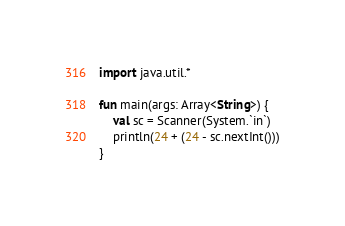<code> <loc_0><loc_0><loc_500><loc_500><_Kotlin_>import java.util.*

fun main(args: Array<String>) {
    val sc = Scanner(System.`in`)
    println(24 + (24 - sc.nextInt()))
}</code> 